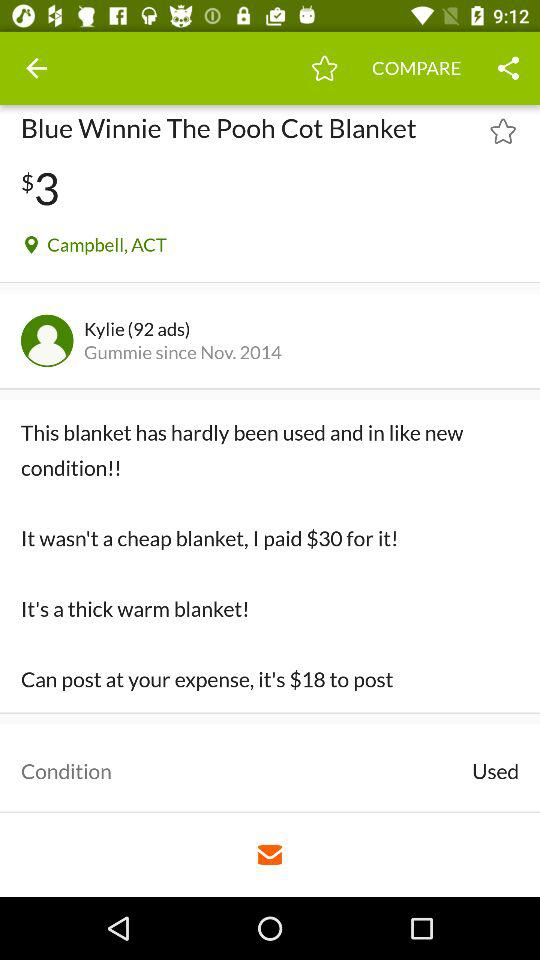What is the price of the "Blue Winnie The Pooh Cot Blanket"? The price of the "Blue Winnie The Pooh Cot Blanket" is $3. 